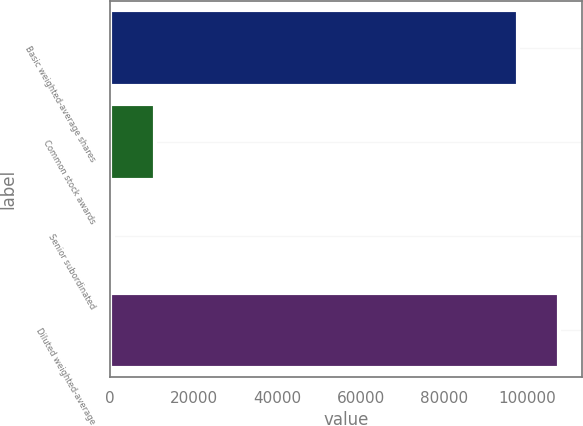<chart> <loc_0><loc_0><loc_500><loc_500><bar_chart><fcel>Basic weighted-average shares<fcel>Common stock awards<fcel>Senior subordinated<fcel>Diluted weighted-average<nl><fcel>97702<fcel>10690.2<fcel>816<fcel>107576<nl></chart> 